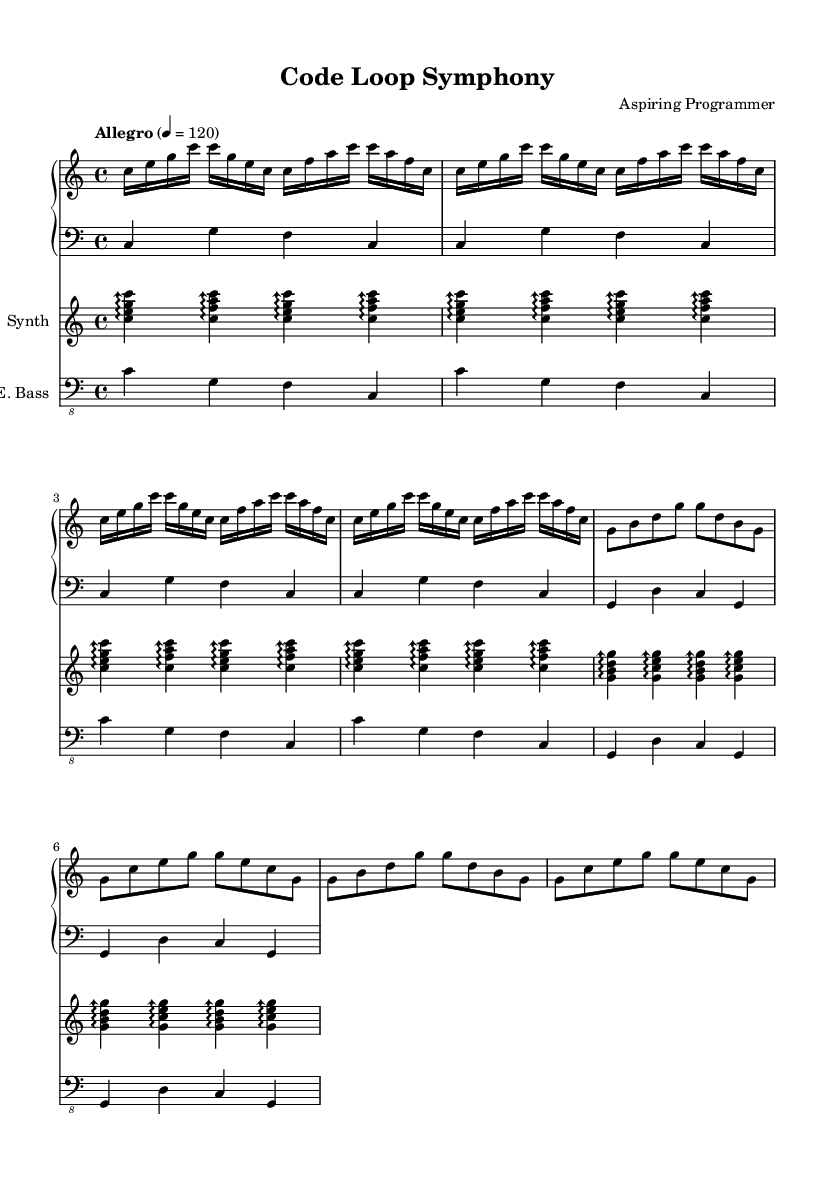what is the key signature of this music? The key signature shown in the music indicates C major, which contains no sharps or flats. This is determined by looking at the key signature at the beginning of the staff.
Answer: C major what is the time signature of this composition? The time signature is indicated just after the key signature. It shows 4/4, meaning there are four beats in a measure and the quarter note receives one beat.
Answer: 4/4 what is the tempo marking for this piece? The tempo marking can be found in the header section of the sheet music. It indicates "Allegro" with a metronome marking of 120 beats per minute, indicating a fast tempo.
Answer: Allegro 4 = 120 how many measures are in the piano right part? By counting the repeated patterns in the music for the piano right part, you can find that there are eight measures: four measures from the first repeated section and two additional measures from the second repeated section.
Answer: 8 what is the role of the synthesizer in this composition? The synthesizer plays arpeggiated chords similar to a harmonic backdrop throughout the piece. It is notable for its repetitive arpeggio patterns that complement the main melody played by the piano.
Answer: Harmonic backdrop how many times is the main motif in the piano right part repeated? The main motif in the piano right part is repeated four times in the first section and two more times in the following section, resulting in a total of six repetitions of the main rhythmic pattern.
Answer: 6 which instruments are included in the score? The score includes a piano (with both right and left hand parts), a synthesizer, and an electric bass, all of which create a layered texture characteristic of minimalist compositions.
Answer: Piano, synthesizer, electric bass 